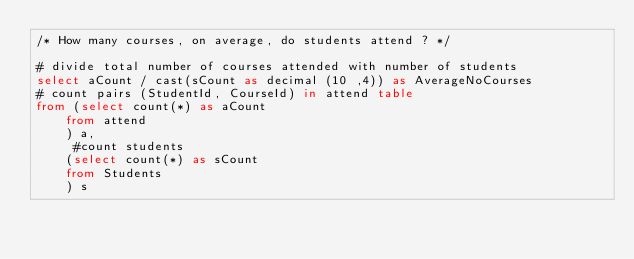<code> <loc_0><loc_0><loc_500><loc_500><_SQL_>/* How many courses, on average, do students attend ? */

# divide total number of courses attended with number of students
select aCount / cast(sCount as decimal (10 ,4)) as AverageNoCourses
# count pairs (StudentId, CourseId) in attend table
from (select count(*) as aCount
    from attend
    ) a,
     #count students
    (select count(*) as sCount
    from Students
    ) s</code> 